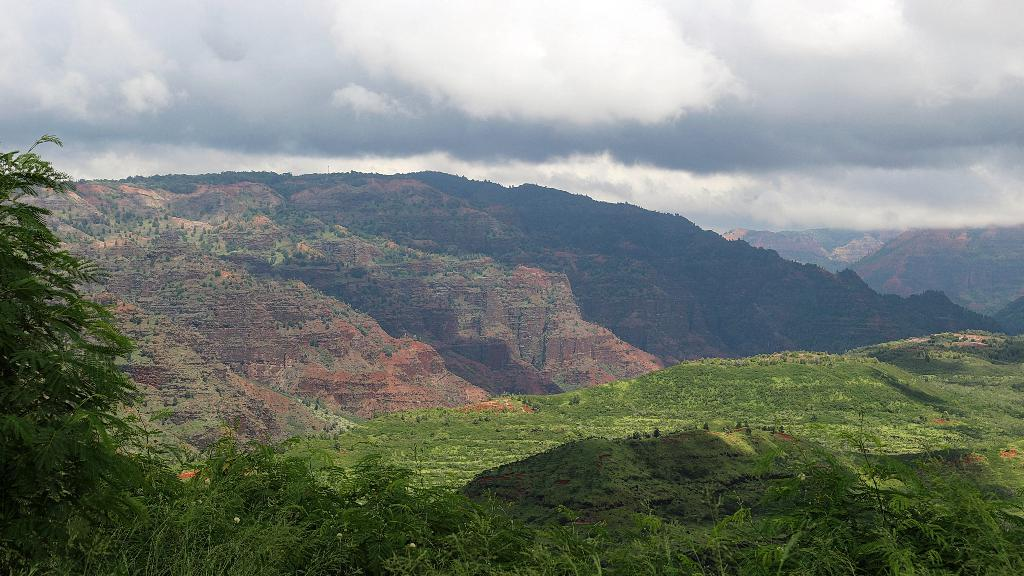What type of vegetation is in the front of the image? There are plants in the front of the image. What is on the ground in the center of the image? There is grass on the ground in the center of the image. What can be seen in the background of the image? There are trees and mountains visible in the background of the image. What is the condition of the sky in the image? The sky is cloudy in the image. Can you see a fireman holding a hen in the image? There is no fireman or hen present in the image. How does the grip of the trees in the background affect the overall composition of the image? There is no mention of the grip of the trees in the provided facts, and the image does not show any trees with a noticeable grip. 